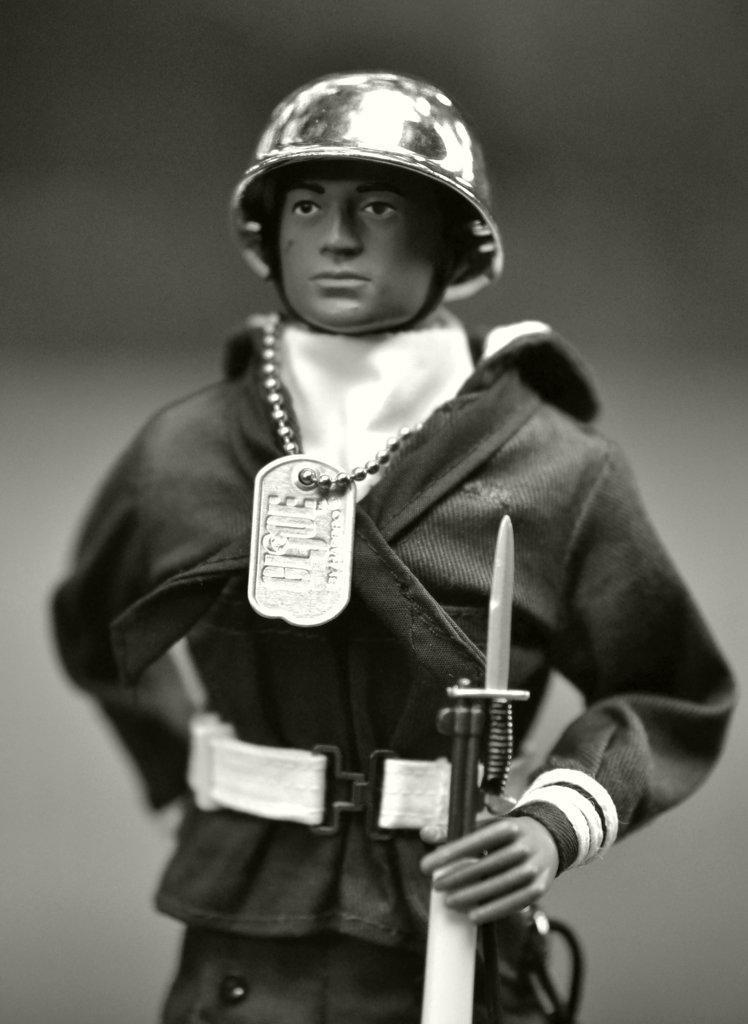How would you summarize this image in a sentence or two? In this image I can see a person standing and holding a weapon. The person is also wearing a chain and a helmet and I can see blurred background, and the image is in black and white. 